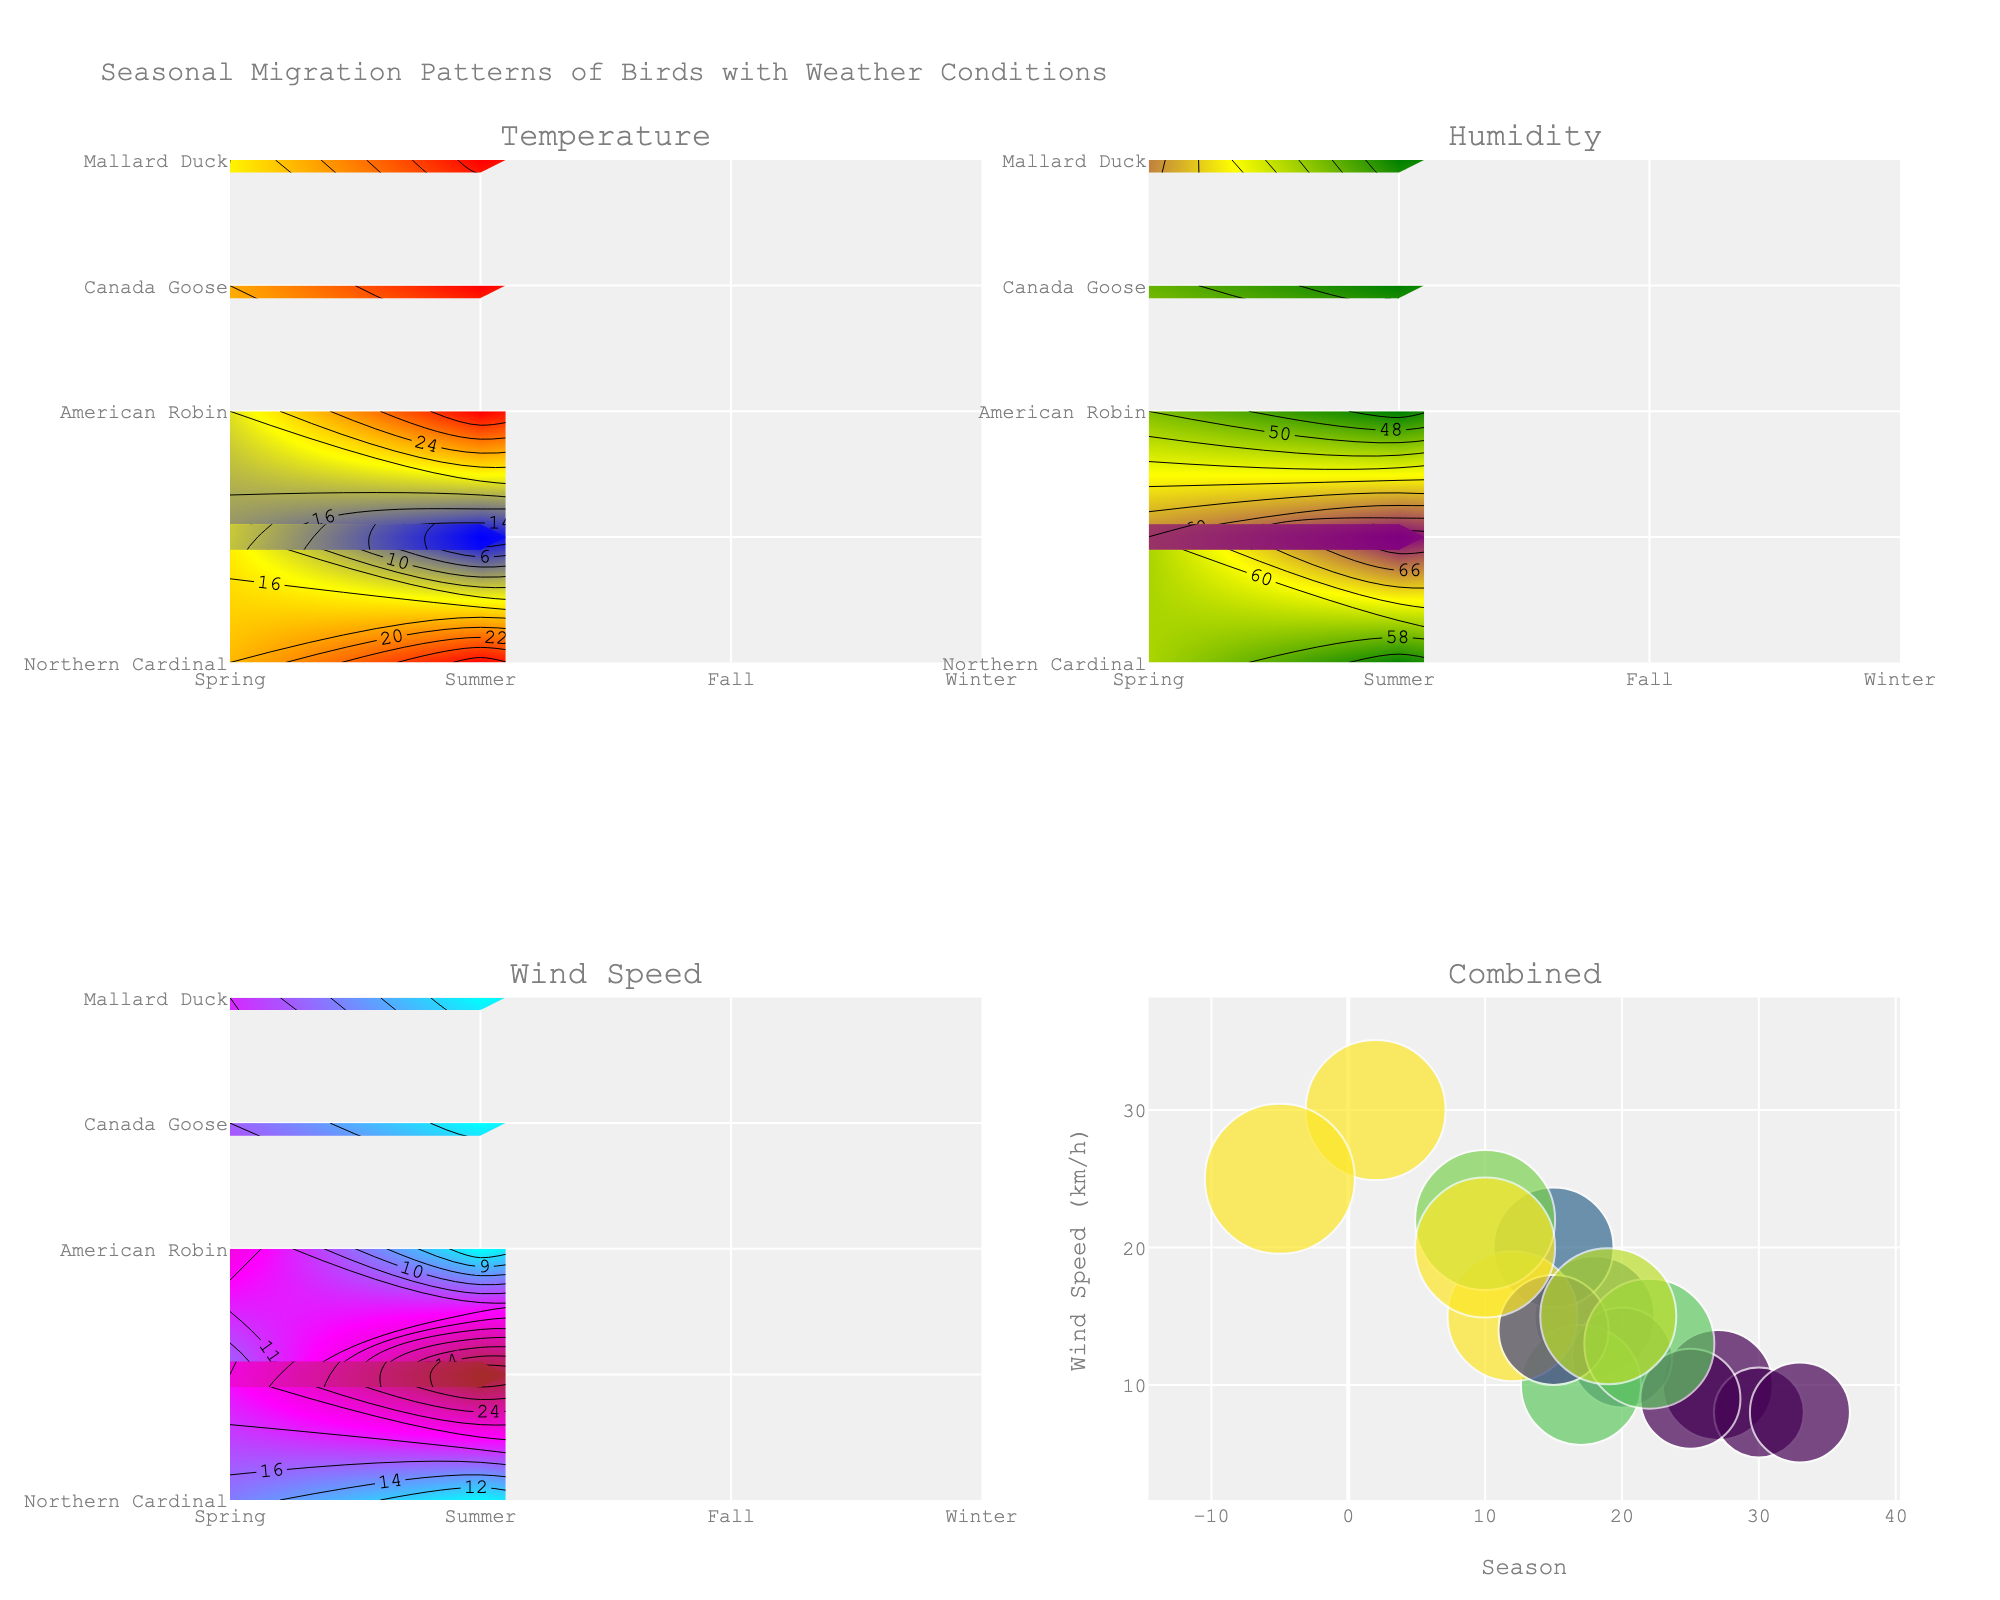What is the title of the figure? The title of the figure is found at the top of the plot and gives a summary of what the plot represents. In this case, it specifies that the figure illustrates seasonal migration patterns and weather conditions for birds.
Answer: Seasonal Migration Patterns of Birds with Weather Conditions Which species has the highest average temperature in Winter? To determine this, look at the Temperature subplot within the Winter section for each species and identify the one with the highest value. The Northern Cardinal shows an average temperature of 2°C, American Robin 12°C, Canada Goose -5°C, and Mallard Duck 10°C.
Answer: American Robin What is the range of wind speed for Canada Goose across seasons? Check the Wind Speed subplot for the Canada Goose across all seasons. The values range from -5 km/h in Winter to 25 km/h in Summer, giving a total range calculated as (25 - (-5)) km/h.
Answer: 30 km/h Which season shows the highest humidity for the Canada Goose? In the Humidity subplot for Canada Goose, observe the values for each season. Spring has 55%, Summer 50%, Fall 70%, and Winter 75%. The highest value is in Winter.
Answer: Winter Compare the scatter points for Mallard Duck, which season has the highest wind speed? The fourth (combined) plot shows scatter points. For Mallard Duck, identify the scatter point with the highest position on the y-axis, which represents the wind speed. Cross-reference the tooltip to confirm the season.
Answer: Winter Which species shows the smallest variation in average temperature between Summer and Winter? Examine the Temperature subplot to compare the Summer and Winter temperatures for each species. Calculate the variation for Northern Cardinal (27 - 2 = 25°C), American Robin (30 - 12 = 18°C), Canada Goose (25 - (-5) = 30°C), Mallard Duck (33 - 10 = 23°C).
Answer: American Robin How does the humidity pattern of Northern Cardinal change from Spring to Winter? In the Humidity subplot, observe Northern Cardinal's humidity values through the seasons: Spring (60%), Summer (55%), Fall (60%), Winter (70%). Describe the trend as increasing slightly then significantly in Winter.
Answer: Increases slightly, then significantly more in Winter Which species has the lowest wind speed in Fall? Look at the Wind Speed subplot for each species during the Fall. Each species is represented by a different contour plot showing average wind speeds. Identify the lowest value. Northern Cardinal displays 20 km/h, American Robin 10 km/h, Canada Goose 22 km/h, and Mallard Duck 15 km/h.
Answer: American Robin Which season generally has the highest temperature for all species? In the Temperature subplot, compare the colors associated with each season across all species. Recognize that Summer consistently shows the highest average temperature for all species.
Answer: Summer 